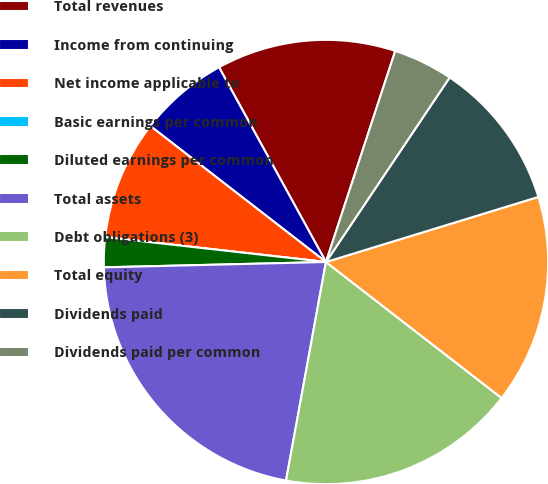Convert chart. <chart><loc_0><loc_0><loc_500><loc_500><pie_chart><fcel>Total revenues<fcel>Income from continuing<fcel>Net income applicable to<fcel>Basic earnings per common<fcel>Diluted earnings per common<fcel>Total assets<fcel>Debt obligations (3)<fcel>Total equity<fcel>Dividends paid<fcel>Dividends paid per common<nl><fcel>13.04%<fcel>6.52%<fcel>8.7%<fcel>0.0%<fcel>2.17%<fcel>21.74%<fcel>17.39%<fcel>15.22%<fcel>10.87%<fcel>4.35%<nl></chart> 